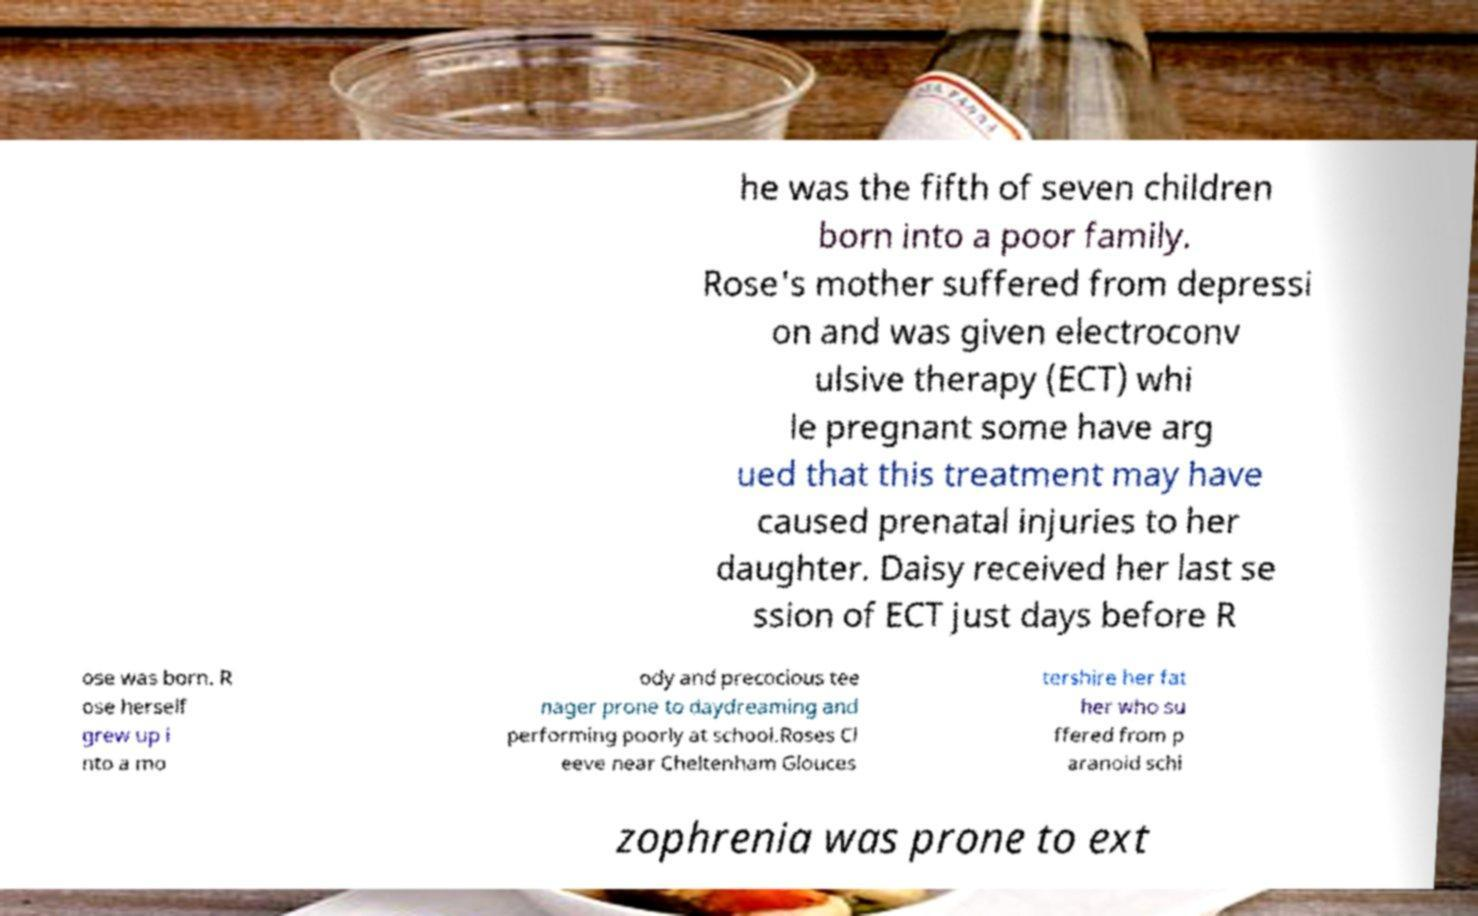Could you assist in decoding the text presented in this image and type it out clearly? he was the fifth of seven children born into a poor family. Rose's mother suffered from depressi on and was given electroconv ulsive therapy (ECT) whi le pregnant some have arg ued that this treatment may have caused prenatal injuries to her daughter. Daisy received her last se ssion of ECT just days before R ose was born. R ose herself grew up i nto a mo ody and precocious tee nager prone to daydreaming and performing poorly at school.Roses Cl eeve near Cheltenham Glouces tershire her fat her who su ffered from p aranoid schi zophrenia was prone to ext 